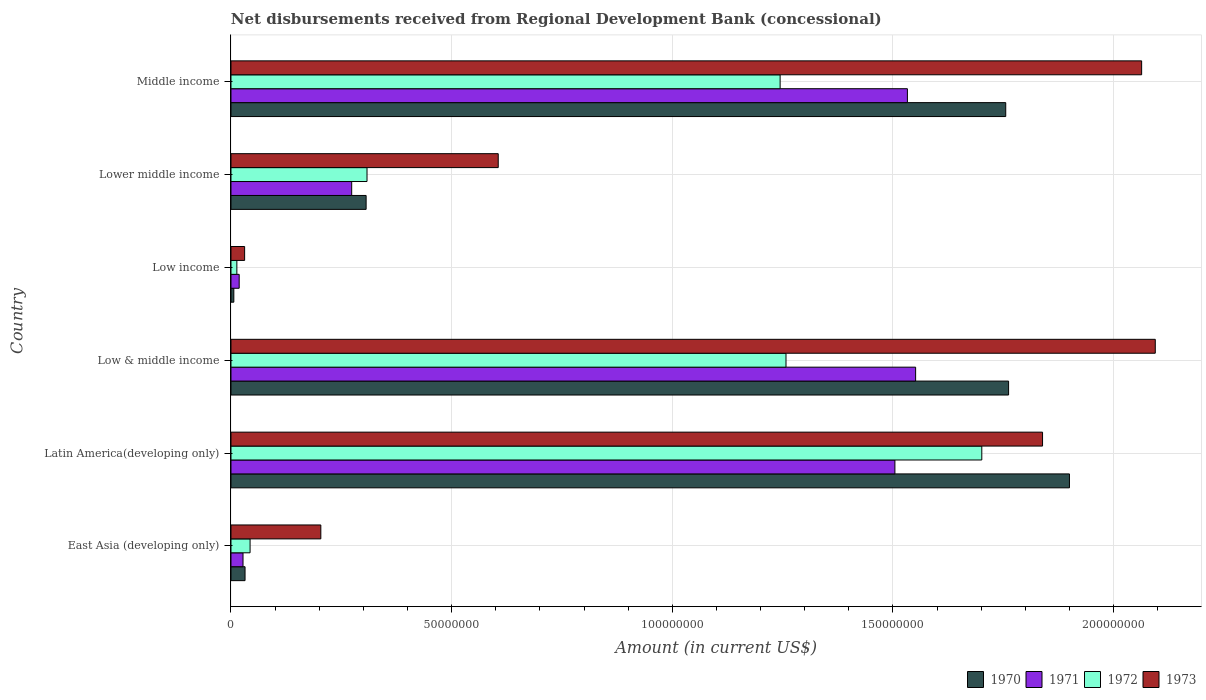How many groups of bars are there?
Give a very brief answer. 6. How many bars are there on the 4th tick from the bottom?
Ensure brevity in your answer.  4. What is the label of the 4th group of bars from the top?
Ensure brevity in your answer.  Low & middle income. What is the amount of disbursements received from Regional Development Bank in 1971 in Low & middle income?
Offer a very short reply. 1.55e+08. Across all countries, what is the maximum amount of disbursements received from Regional Development Bank in 1971?
Keep it short and to the point. 1.55e+08. Across all countries, what is the minimum amount of disbursements received from Regional Development Bank in 1972?
Your answer should be compact. 1.33e+06. What is the total amount of disbursements received from Regional Development Bank in 1970 in the graph?
Offer a terse response. 5.76e+08. What is the difference between the amount of disbursements received from Regional Development Bank in 1973 in East Asia (developing only) and that in Low income?
Give a very brief answer. 1.73e+07. What is the difference between the amount of disbursements received from Regional Development Bank in 1971 in Middle income and the amount of disbursements received from Regional Development Bank in 1973 in East Asia (developing only)?
Your answer should be very brief. 1.33e+08. What is the average amount of disbursements received from Regional Development Bank in 1970 per country?
Provide a short and direct response. 9.60e+07. What is the difference between the amount of disbursements received from Regional Development Bank in 1973 and amount of disbursements received from Regional Development Bank in 1972 in Low & middle income?
Give a very brief answer. 8.37e+07. What is the ratio of the amount of disbursements received from Regional Development Bank in 1973 in Low & middle income to that in Low income?
Offer a terse response. 67.76. Is the amount of disbursements received from Regional Development Bank in 1970 in East Asia (developing only) less than that in Latin America(developing only)?
Your response must be concise. Yes. Is the difference between the amount of disbursements received from Regional Development Bank in 1973 in East Asia (developing only) and Low income greater than the difference between the amount of disbursements received from Regional Development Bank in 1972 in East Asia (developing only) and Low income?
Make the answer very short. Yes. What is the difference between the highest and the second highest amount of disbursements received from Regional Development Bank in 1973?
Give a very brief answer. 3.09e+06. What is the difference between the highest and the lowest amount of disbursements received from Regional Development Bank in 1972?
Make the answer very short. 1.69e+08. Is the sum of the amount of disbursements received from Regional Development Bank in 1973 in Low income and Middle income greater than the maximum amount of disbursements received from Regional Development Bank in 1970 across all countries?
Make the answer very short. Yes. What does the 1st bar from the bottom in Latin America(developing only) represents?
Give a very brief answer. 1970. Is it the case that in every country, the sum of the amount of disbursements received from Regional Development Bank in 1970 and amount of disbursements received from Regional Development Bank in 1971 is greater than the amount of disbursements received from Regional Development Bank in 1972?
Make the answer very short. Yes. How many bars are there?
Provide a short and direct response. 24. Does the graph contain any zero values?
Offer a terse response. No. Does the graph contain grids?
Make the answer very short. Yes. What is the title of the graph?
Your answer should be compact. Net disbursements received from Regional Development Bank (concessional). What is the Amount (in current US$) of 1970 in East Asia (developing only)?
Ensure brevity in your answer.  3.19e+06. What is the Amount (in current US$) in 1971 in East Asia (developing only)?
Offer a very short reply. 2.73e+06. What is the Amount (in current US$) in 1972 in East Asia (developing only)?
Offer a terse response. 4.33e+06. What is the Amount (in current US$) of 1973 in East Asia (developing only)?
Your response must be concise. 2.04e+07. What is the Amount (in current US$) in 1970 in Latin America(developing only)?
Offer a terse response. 1.90e+08. What is the Amount (in current US$) of 1971 in Latin America(developing only)?
Your answer should be compact. 1.50e+08. What is the Amount (in current US$) in 1972 in Latin America(developing only)?
Make the answer very short. 1.70e+08. What is the Amount (in current US$) in 1973 in Latin America(developing only)?
Ensure brevity in your answer.  1.84e+08. What is the Amount (in current US$) of 1970 in Low & middle income?
Give a very brief answer. 1.76e+08. What is the Amount (in current US$) of 1971 in Low & middle income?
Your answer should be compact. 1.55e+08. What is the Amount (in current US$) in 1972 in Low & middle income?
Your answer should be very brief. 1.26e+08. What is the Amount (in current US$) of 1973 in Low & middle income?
Give a very brief answer. 2.09e+08. What is the Amount (in current US$) of 1970 in Low income?
Provide a short and direct response. 6.47e+05. What is the Amount (in current US$) of 1971 in Low income?
Offer a very short reply. 1.86e+06. What is the Amount (in current US$) of 1972 in Low income?
Offer a terse response. 1.33e+06. What is the Amount (in current US$) of 1973 in Low income?
Offer a terse response. 3.09e+06. What is the Amount (in current US$) of 1970 in Lower middle income?
Offer a terse response. 3.06e+07. What is the Amount (in current US$) in 1971 in Lower middle income?
Make the answer very short. 2.74e+07. What is the Amount (in current US$) of 1972 in Lower middle income?
Offer a terse response. 3.08e+07. What is the Amount (in current US$) of 1973 in Lower middle income?
Ensure brevity in your answer.  6.06e+07. What is the Amount (in current US$) of 1970 in Middle income?
Ensure brevity in your answer.  1.76e+08. What is the Amount (in current US$) in 1971 in Middle income?
Keep it short and to the point. 1.53e+08. What is the Amount (in current US$) in 1972 in Middle income?
Offer a terse response. 1.24e+08. What is the Amount (in current US$) of 1973 in Middle income?
Your answer should be very brief. 2.06e+08. Across all countries, what is the maximum Amount (in current US$) in 1970?
Keep it short and to the point. 1.90e+08. Across all countries, what is the maximum Amount (in current US$) in 1971?
Your response must be concise. 1.55e+08. Across all countries, what is the maximum Amount (in current US$) in 1972?
Give a very brief answer. 1.70e+08. Across all countries, what is the maximum Amount (in current US$) in 1973?
Offer a very short reply. 2.09e+08. Across all countries, what is the minimum Amount (in current US$) in 1970?
Your response must be concise. 6.47e+05. Across all countries, what is the minimum Amount (in current US$) of 1971?
Offer a terse response. 1.86e+06. Across all countries, what is the minimum Amount (in current US$) in 1972?
Keep it short and to the point. 1.33e+06. Across all countries, what is the minimum Amount (in current US$) in 1973?
Provide a succinct answer. 3.09e+06. What is the total Amount (in current US$) of 1970 in the graph?
Provide a succinct answer. 5.76e+08. What is the total Amount (in current US$) in 1971 in the graph?
Your response must be concise. 4.91e+08. What is the total Amount (in current US$) of 1972 in the graph?
Give a very brief answer. 4.57e+08. What is the total Amount (in current US$) in 1973 in the graph?
Offer a very short reply. 6.84e+08. What is the difference between the Amount (in current US$) of 1970 in East Asia (developing only) and that in Latin America(developing only)?
Give a very brief answer. -1.87e+08. What is the difference between the Amount (in current US$) in 1971 in East Asia (developing only) and that in Latin America(developing only)?
Provide a short and direct response. -1.48e+08. What is the difference between the Amount (in current US$) of 1972 in East Asia (developing only) and that in Latin America(developing only)?
Offer a very short reply. -1.66e+08. What is the difference between the Amount (in current US$) of 1973 in East Asia (developing only) and that in Latin America(developing only)?
Provide a succinct answer. -1.64e+08. What is the difference between the Amount (in current US$) in 1970 in East Asia (developing only) and that in Low & middle income?
Ensure brevity in your answer.  -1.73e+08. What is the difference between the Amount (in current US$) in 1971 in East Asia (developing only) and that in Low & middle income?
Your response must be concise. -1.52e+08. What is the difference between the Amount (in current US$) of 1972 in East Asia (developing only) and that in Low & middle income?
Your response must be concise. -1.21e+08. What is the difference between the Amount (in current US$) of 1973 in East Asia (developing only) and that in Low & middle income?
Ensure brevity in your answer.  -1.89e+08. What is the difference between the Amount (in current US$) of 1970 in East Asia (developing only) and that in Low income?
Offer a very short reply. 2.54e+06. What is the difference between the Amount (in current US$) in 1971 in East Asia (developing only) and that in Low income?
Offer a very short reply. 8.69e+05. What is the difference between the Amount (in current US$) in 1972 in East Asia (developing only) and that in Low income?
Ensure brevity in your answer.  2.99e+06. What is the difference between the Amount (in current US$) of 1973 in East Asia (developing only) and that in Low income?
Provide a succinct answer. 1.73e+07. What is the difference between the Amount (in current US$) of 1970 in East Asia (developing only) and that in Lower middle income?
Ensure brevity in your answer.  -2.74e+07. What is the difference between the Amount (in current US$) in 1971 in East Asia (developing only) and that in Lower middle income?
Offer a very short reply. -2.46e+07. What is the difference between the Amount (in current US$) in 1972 in East Asia (developing only) and that in Lower middle income?
Your response must be concise. -2.65e+07. What is the difference between the Amount (in current US$) in 1973 in East Asia (developing only) and that in Lower middle income?
Give a very brief answer. -4.02e+07. What is the difference between the Amount (in current US$) in 1970 in East Asia (developing only) and that in Middle income?
Your answer should be compact. -1.72e+08. What is the difference between the Amount (in current US$) of 1971 in East Asia (developing only) and that in Middle income?
Offer a very short reply. -1.51e+08. What is the difference between the Amount (in current US$) in 1972 in East Asia (developing only) and that in Middle income?
Offer a very short reply. -1.20e+08. What is the difference between the Amount (in current US$) in 1973 in East Asia (developing only) and that in Middle income?
Offer a terse response. -1.86e+08. What is the difference between the Amount (in current US$) of 1970 in Latin America(developing only) and that in Low & middle income?
Provide a succinct answer. 1.38e+07. What is the difference between the Amount (in current US$) of 1971 in Latin America(developing only) and that in Low & middle income?
Give a very brief answer. -4.69e+06. What is the difference between the Amount (in current US$) of 1972 in Latin America(developing only) and that in Low & middle income?
Offer a very short reply. 4.44e+07. What is the difference between the Amount (in current US$) in 1973 in Latin America(developing only) and that in Low & middle income?
Keep it short and to the point. -2.55e+07. What is the difference between the Amount (in current US$) of 1970 in Latin America(developing only) and that in Low income?
Offer a very short reply. 1.89e+08. What is the difference between the Amount (in current US$) of 1971 in Latin America(developing only) and that in Low income?
Your response must be concise. 1.49e+08. What is the difference between the Amount (in current US$) of 1972 in Latin America(developing only) and that in Low income?
Give a very brief answer. 1.69e+08. What is the difference between the Amount (in current US$) in 1973 in Latin America(developing only) and that in Low income?
Your answer should be compact. 1.81e+08. What is the difference between the Amount (in current US$) in 1970 in Latin America(developing only) and that in Lower middle income?
Your response must be concise. 1.59e+08. What is the difference between the Amount (in current US$) of 1971 in Latin America(developing only) and that in Lower middle income?
Make the answer very short. 1.23e+08. What is the difference between the Amount (in current US$) of 1972 in Latin America(developing only) and that in Lower middle income?
Provide a succinct answer. 1.39e+08. What is the difference between the Amount (in current US$) of 1973 in Latin America(developing only) and that in Lower middle income?
Your answer should be compact. 1.23e+08. What is the difference between the Amount (in current US$) of 1970 in Latin America(developing only) and that in Middle income?
Offer a terse response. 1.44e+07. What is the difference between the Amount (in current US$) of 1971 in Latin America(developing only) and that in Middle income?
Your answer should be compact. -2.84e+06. What is the difference between the Amount (in current US$) of 1972 in Latin America(developing only) and that in Middle income?
Your answer should be very brief. 4.57e+07. What is the difference between the Amount (in current US$) of 1973 in Latin America(developing only) and that in Middle income?
Your answer should be very brief. -2.25e+07. What is the difference between the Amount (in current US$) in 1970 in Low & middle income and that in Low income?
Offer a very short reply. 1.76e+08. What is the difference between the Amount (in current US$) of 1971 in Low & middle income and that in Low income?
Provide a short and direct response. 1.53e+08. What is the difference between the Amount (in current US$) in 1972 in Low & middle income and that in Low income?
Ensure brevity in your answer.  1.24e+08. What is the difference between the Amount (in current US$) of 1973 in Low & middle income and that in Low income?
Provide a succinct answer. 2.06e+08. What is the difference between the Amount (in current US$) of 1970 in Low & middle income and that in Lower middle income?
Ensure brevity in your answer.  1.46e+08. What is the difference between the Amount (in current US$) of 1971 in Low & middle income and that in Lower middle income?
Provide a succinct answer. 1.28e+08. What is the difference between the Amount (in current US$) in 1972 in Low & middle income and that in Lower middle income?
Ensure brevity in your answer.  9.49e+07. What is the difference between the Amount (in current US$) of 1973 in Low & middle income and that in Lower middle income?
Give a very brief answer. 1.49e+08. What is the difference between the Amount (in current US$) of 1970 in Low & middle income and that in Middle income?
Make the answer very short. 6.47e+05. What is the difference between the Amount (in current US$) of 1971 in Low & middle income and that in Middle income?
Offer a very short reply. 1.86e+06. What is the difference between the Amount (in current US$) of 1972 in Low & middle income and that in Middle income?
Your answer should be compact. 1.33e+06. What is the difference between the Amount (in current US$) in 1973 in Low & middle income and that in Middle income?
Offer a very short reply. 3.09e+06. What is the difference between the Amount (in current US$) of 1970 in Low income and that in Lower middle income?
Your answer should be very brief. -3.00e+07. What is the difference between the Amount (in current US$) of 1971 in Low income and that in Lower middle income?
Offer a terse response. -2.55e+07. What is the difference between the Amount (in current US$) in 1972 in Low income and that in Lower middle income?
Your answer should be very brief. -2.95e+07. What is the difference between the Amount (in current US$) of 1973 in Low income and that in Lower middle income?
Give a very brief answer. -5.75e+07. What is the difference between the Amount (in current US$) in 1970 in Low income and that in Middle income?
Offer a very short reply. -1.75e+08. What is the difference between the Amount (in current US$) in 1971 in Low income and that in Middle income?
Provide a succinct answer. -1.51e+08. What is the difference between the Amount (in current US$) in 1972 in Low income and that in Middle income?
Offer a very short reply. -1.23e+08. What is the difference between the Amount (in current US$) of 1973 in Low income and that in Middle income?
Your answer should be compact. -2.03e+08. What is the difference between the Amount (in current US$) of 1970 in Lower middle income and that in Middle income?
Keep it short and to the point. -1.45e+08. What is the difference between the Amount (in current US$) in 1971 in Lower middle income and that in Middle income?
Make the answer very short. -1.26e+08. What is the difference between the Amount (in current US$) of 1972 in Lower middle income and that in Middle income?
Keep it short and to the point. -9.36e+07. What is the difference between the Amount (in current US$) in 1973 in Lower middle income and that in Middle income?
Provide a succinct answer. -1.46e+08. What is the difference between the Amount (in current US$) of 1970 in East Asia (developing only) and the Amount (in current US$) of 1971 in Latin America(developing only)?
Offer a terse response. -1.47e+08. What is the difference between the Amount (in current US$) in 1970 in East Asia (developing only) and the Amount (in current US$) in 1972 in Latin America(developing only)?
Your answer should be compact. -1.67e+08. What is the difference between the Amount (in current US$) of 1970 in East Asia (developing only) and the Amount (in current US$) of 1973 in Latin America(developing only)?
Keep it short and to the point. -1.81e+08. What is the difference between the Amount (in current US$) in 1971 in East Asia (developing only) and the Amount (in current US$) in 1972 in Latin America(developing only)?
Your response must be concise. -1.67e+08. What is the difference between the Amount (in current US$) of 1971 in East Asia (developing only) and the Amount (in current US$) of 1973 in Latin America(developing only)?
Your response must be concise. -1.81e+08. What is the difference between the Amount (in current US$) of 1972 in East Asia (developing only) and the Amount (in current US$) of 1973 in Latin America(developing only)?
Provide a succinct answer. -1.80e+08. What is the difference between the Amount (in current US$) of 1970 in East Asia (developing only) and the Amount (in current US$) of 1971 in Low & middle income?
Give a very brief answer. -1.52e+08. What is the difference between the Amount (in current US$) of 1970 in East Asia (developing only) and the Amount (in current US$) of 1972 in Low & middle income?
Give a very brief answer. -1.23e+08. What is the difference between the Amount (in current US$) in 1970 in East Asia (developing only) and the Amount (in current US$) in 1973 in Low & middle income?
Your answer should be very brief. -2.06e+08. What is the difference between the Amount (in current US$) of 1971 in East Asia (developing only) and the Amount (in current US$) of 1972 in Low & middle income?
Your response must be concise. -1.23e+08. What is the difference between the Amount (in current US$) in 1971 in East Asia (developing only) and the Amount (in current US$) in 1973 in Low & middle income?
Your answer should be very brief. -2.07e+08. What is the difference between the Amount (in current US$) of 1972 in East Asia (developing only) and the Amount (in current US$) of 1973 in Low & middle income?
Keep it short and to the point. -2.05e+08. What is the difference between the Amount (in current US$) in 1970 in East Asia (developing only) and the Amount (in current US$) in 1971 in Low income?
Provide a short and direct response. 1.33e+06. What is the difference between the Amount (in current US$) of 1970 in East Asia (developing only) and the Amount (in current US$) of 1972 in Low income?
Your response must be concise. 1.86e+06. What is the difference between the Amount (in current US$) in 1970 in East Asia (developing only) and the Amount (in current US$) in 1973 in Low income?
Ensure brevity in your answer.  9.80e+04. What is the difference between the Amount (in current US$) in 1971 in East Asia (developing only) and the Amount (in current US$) in 1972 in Low income?
Keep it short and to the point. 1.40e+06. What is the difference between the Amount (in current US$) of 1971 in East Asia (developing only) and the Amount (in current US$) of 1973 in Low income?
Provide a short and direct response. -3.63e+05. What is the difference between the Amount (in current US$) of 1972 in East Asia (developing only) and the Amount (in current US$) of 1973 in Low income?
Offer a terse response. 1.24e+06. What is the difference between the Amount (in current US$) of 1970 in East Asia (developing only) and the Amount (in current US$) of 1971 in Lower middle income?
Offer a terse response. -2.42e+07. What is the difference between the Amount (in current US$) of 1970 in East Asia (developing only) and the Amount (in current US$) of 1972 in Lower middle income?
Ensure brevity in your answer.  -2.76e+07. What is the difference between the Amount (in current US$) in 1970 in East Asia (developing only) and the Amount (in current US$) in 1973 in Lower middle income?
Provide a succinct answer. -5.74e+07. What is the difference between the Amount (in current US$) of 1971 in East Asia (developing only) and the Amount (in current US$) of 1972 in Lower middle income?
Offer a terse response. -2.81e+07. What is the difference between the Amount (in current US$) in 1971 in East Asia (developing only) and the Amount (in current US$) in 1973 in Lower middle income?
Ensure brevity in your answer.  -5.78e+07. What is the difference between the Amount (in current US$) of 1972 in East Asia (developing only) and the Amount (in current US$) of 1973 in Lower middle income?
Provide a succinct answer. -5.62e+07. What is the difference between the Amount (in current US$) in 1970 in East Asia (developing only) and the Amount (in current US$) in 1971 in Middle income?
Provide a succinct answer. -1.50e+08. What is the difference between the Amount (in current US$) in 1970 in East Asia (developing only) and the Amount (in current US$) in 1972 in Middle income?
Your answer should be very brief. -1.21e+08. What is the difference between the Amount (in current US$) in 1970 in East Asia (developing only) and the Amount (in current US$) in 1973 in Middle income?
Give a very brief answer. -2.03e+08. What is the difference between the Amount (in current US$) of 1971 in East Asia (developing only) and the Amount (in current US$) of 1972 in Middle income?
Provide a short and direct response. -1.22e+08. What is the difference between the Amount (in current US$) of 1971 in East Asia (developing only) and the Amount (in current US$) of 1973 in Middle income?
Provide a short and direct response. -2.04e+08. What is the difference between the Amount (in current US$) of 1972 in East Asia (developing only) and the Amount (in current US$) of 1973 in Middle income?
Ensure brevity in your answer.  -2.02e+08. What is the difference between the Amount (in current US$) of 1970 in Latin America(developing only) and the Amount (in current US$) of 1971 in Low & middle income?
Make the answer very short. 3.49e+07. What is the difference between the Amount (in current US$) in 1970 in Latin America(developing only) and the Amount (in current US$) in 1972 in Low & middle income?
Keep it short and to the point. 6.42e+07. What is the difference between the Amount (in current US$) of 1970 in Latin America(developing only) and the Amount (in current US$) of 1973 in Low & middle income?
Your response must be concise. -1.94e+07. What is the difference between the Amount (in current US$) of 1971 in Latin America(developing only) and the Amount (in current US$) of 1972 in Low & middle income?
Make the answer very short. 2.47e+07. What is the difference between the Amount (in current US$) in 1971 in Latin America(developing only) and the Amount (in current US$) in 1973 in Low & middle income?
Keep it short and to the point. -5.90e+07. What is the difference between the Amount (in current US$) in 1972 in Latin America(developing only) and the Amount (in current US$) in 1973 in Low & middle income?
Ensure brevity in your answer.  -3.93e+07. What is the difference between the Amount (in current US$) in 1970 in Latin America(developing only) and the Amount (in current US$) in 1971 in Low income?
Offer a very short reply. 1.88e+08. What is the difference between the Amount (in current US$) of 1970 in Latin America(developing only) and the Amount (in current US$) of 1972 in Low income?
Provide a short and direct response. 1.89e+08. What is the difference between the Amount (in current US$) in 1970 in Latin America(developing only) and the Amount (in current US$) in 1973 in Low income?
Make the answer very short. 1.87e+08. What is the difference between the Amount (in current US$) in 1971 in Latin America(developing only) and the Amount (in current US$) in 1972 in Low income?
Give a very brief answer. 1.49e+08. What is the difference between the Amount (in current US$) in 1971 in Latin America(developing only) and the Amount (in current US$) in 1973 in Low income?
Keep it short and to the point. 1.47e+08. What is the difference between the Amount (in current US$) in 1972 in Latin America(developing only) and the Amount (in current US$) in 1973 in Low income?
Give a very brief answer. 1.67e+08. What is the difference between the Amount (in current US$) of 1970 in Latin America(developing only) and the Amount (in current US$) of 1971 in Lower middle income?
Offer a terse response. 1.63e+08. What is the difference between the Amount (in current US$) of 1970 in Latin America(developing only) and the Amount (in current US$) of 1972 in Lower middle income?
Offer a terse response. 1.59e+08. What is the difference between the Amount (in current US$) in 1970 in Latin America(developing only) and the Amount (in current US$) in 1973 in Lower middle income?
Offer a terse response. 1.29e+08. What is the difference between the Amount (in current US$) of 1971 in Latin America(developing only) and the Amount (in current US$) of 1972 in Lower middle income?
Make the answer very short. 1.20e+08. What is the difference between the Amount (in current US$) in 1971 in Latin America(developing only) and the Amount (in current US$) in 1973 in Lower middle income?
Your answer should be compact. 8.99e+07. What is the difference between the Amount (in current US$) of 1972 in Latin America(developing only) and the Amount (in current US$) of 1973 in Lower middle income?
Your answer should be compact. 1.10e+08. What is the difference between the Amount (in current US$) of 1970 in Latin America(developing only) and the Amount (in current US$) of 1971 in Middle income?
Give a very brief answer. 3.67e+07. What is the difference between the Amount (in current US$) of 1970 in Latin America(developing only) and the Amount (in current US$) of 1972 in Middle income?
Offer a terse response. 6.56e+07. What is the difference between the Amount (in current US$) of 1970 in Latin America(developing only) and the Amount (in current US$) of 1973 in Middle income?
Keep it short and to the point. -1.64e+07. What is the difference between the Amount (in current US$) of 1971 in Latin America(developing only) and the Amount (in current US$) of 1972 in Middle income?
Provide a short and direct response. 2.60e+07. What is the difference between the Amount (in current US$) of 1971 in Latin America(developing only) and the Amount (in current US$) of 1973 in Middle income?
Ensure brevity in your answer.  -5.59e+07. What is the difference between the Amount (in current US$) of 1972 in Latin America(developing only) and the Amount (in current US$) of 1973 in Middle income?
Your answer should be very brief. -3.62e+07. What is the difference between the Amount (in current US$) in 1970 in Low & middle income and the Amount (in current US$) in 1971 in Low income?
Offer a very short reply. 1.74e+08. What is the difference between the Amount (in current US$) in 1970 in Low & middle income and the Amount (in current US$) in 1972 in Low income?
Offer a terse response. 1.75e+08. What is the difference between the Amount (in current US$) in 1970 in Low & middle income and the Amount (in current US$) in 1973 in Low income?
Your answer should be compact. 1.73e+08. What is the difference between the Amount (in current US$) of 1971 in Low & middle income and the Amount (in current US$) of 1972 in Low income?
Make the answer very short. 1.54e+08. What is the difference between the Amount (in current US$) of 1971 in Low & middle income and the Amount (in current US$) of 1973 in Low income?
Your answer should be very brief. 1.52e+08. What is the difference between the Amount (in current US$) in 1972 in Low & middle income and the Amount (in current US$) in 1973 in Low income?
Ensure brevity in your answer.  1.23e+08. What is the difference between the Amount (in current US$) in 1970 in Low & middle income and the Amount (in current US$) in 1971 in Lower middle income?
Give a very brief answer. 1.49e+08. What is the difference between the Amount (in current US$) in 1970 in Low & middle income and the Amount (in current US$) in 1972 in Lower middle income?
Your answer should be compact. 1.45e+08. What is the difference between the Amount (in current US$) of 1970 in Low & middle income and the Amount (in current US$) of 1973 in Lower middle income?
Give a very brief answer. 1.16e+08. What is the difference between the Amount (in current US$) of 1971 in Low & middle income and the Amount (in current US$) of 1972 in Lower middle income?
Ensure brevity in your answer.  1.24e+08. What is the difference between the Amount (in current US$) of 1971 in Low & middle income and the Amount (in current US$) of 1973 in Lower middle income?
Keep it short and to the point. 9.46e+07. What is the difference between the Amount (in current US$) of 1972 in Low & middle income and the Amount (in current US$) of 1973 in Lower middle income?
Provide a short and direct response. 6.52e+07. What is the difference between the Amount (in current US$) of 1970 in Low & middle income and the Amount (in current US$) of 1971 in Middle income?
Offer a terse response. 2.29e+07. What is the difference between the Amount (in current US$) of 1970 in Low & middle income and the Amount (in current US$) of 1972 in Middle income?
Give a very brief answer. 5.18e+07. What is the difference between the Amount (in current US$) of 1970 in Low & middle income and the Amount (in current US$) of 1973 in Middle income?
Your answer should be very brief. -3.01e+07. What is the difference between the Amount (in current US$) of 1971 in Low & middle income and the Amount (in current US$) of 1972 in Middle income?
Offer a terse response. 3.07e+07. What is the difference between the Amount (in current US$) in 1971 in Low & middle income and the Amount (in current US$) in 1973 in Middle income?
Your answer should be very brief. -5.12e+07. What is the difference between the Amount (in current US$) of 1972 in Low & middle income and the Amount (in current US$) of 1973 in Middle income?
Give a very brief answer. -8.06e+07. What is the difference between the Amount (in current US$) of 1970 in Low income and the Amount (in current US$) of 1971 in Lower middle income?
Your answer should be compact. -2.67e+07. What is the difference between the Amount (in current US$) in 1970 in Low income and the Amount (in current US$) in 1972 in Lower middle income?
Provide a succinct answer. -3.02e+07. What is the difference between the Amount (in current US$) in 1970 in Low income and the Amount (in current US$) in 1973 in Lower middle income?
Offer a terse response. -5.99e+07. What is the difference between the Amount (in current US$) of 1971 in Low income and the Amount (in current US$) of 1972 in Lower middle income?
Provide a succinct answer. -2.90e+07. What is the difference between the Amount (in current US$) in 1971 in Low income and the Amount (in current US$) in 1973 in Lower middle income?
Your answer should be very brief. -5.87e+07. What is the difference between the Amount (in current US$) in 1972 in Low income and the Amount (in current US$) in 1973 in Lower middle income?
Offer a very short reply. -5.92e+07. What is the difference between the Amount (in current US$) of 1970 in Low income and the Amount (in current US$) of 1971 in Middle income?
Ensure brevity in your answer.  -1.53e+08. What is the difference between the Amount (in current US$) of 1970 in Low income and the Amount (in current US$) of 1972 in Middle income?
Provide a short and direct response. -1.24e+08. What is the difference between the Amount (in current US$) of 1970 in Low income and the Amount (in current US$) of 1973 in Middle income?
Provide a succinct answer. -2.06e+08. What is the difference between the Amount (in current US$) of 1971 in Low income and the Amount (in current US$) of 1972 in Middle income?
Your answer should be compact. -1.23e+08. What is the difference between the Amount (in current US$) in 1971 in Low income and the Amount (in current US$) in 1973 in Middle income?
Offer a terse response. -2.04e+08. What is the difference between the Amount (in current US$) of 1972 in Low income and the Amount (in current US$) of 1973 in Middle income?
Keep it short and to the point. -2.05e+08. What is the difference between the Amount (in current US$) in 1970 in Lower middle income and the Amount (in current US$) in 1971 in Middle income?
Keep it short and to the point. -1.23e+08. What is the difference between the Amount (in current US$) of 1970 in Lower middle income and the Amount (in current US$) of 1972 in Middle income?
Make the answer very short. -9.38e+07. What is the difference between the Amount (in current US$) in 1970 in Lower middle income and the Amount (in current US$) in 1973 in Middle income?
Your answer should be very brief. -1.76e+08. What is the difference between the Amount (in current US$) of 1971 in Lower middle income and the Amount (in current US$) of 1972 in Middle income?
Keep it short and to the point. -9.71e+07. What is the difference between the Amount (in current US$) of 1971 in Lower middle income and the Amount (in current US$) of 1973 in Middle income?
Provide a succinct answer. -1.79e+08. What is the difference between the Amount (in current US$) in 1972 in Lower middle income and the Amount (in current US$) in 1973 in Middle income?
Ensure brevity in your answer.  -1.76e+08. What is the average Amount (in current US$) in 1970 per country?
Keep it short and to the point. 9.60e+07. What is the average Amount (in current US$) in 1971 per country?
Provide a short and direct response. 8.18e+07. What is the average Amount (in current US$) of 1972 per country?
Keep it short and to the point. 7.61e+07. What is the average Amount (in current US$) in 1973 per country?
Offer a very short reply. 1.14e+08. What is the difference between the Amount (in current US$) of 1970 and Amount (in current US$) of 1971 in East Asia (developing only)?
Your answer should be compact. 4.61e+05. What is the difference between the Amount (in current US$) in 1970 and Amount (in current US$) in 1972 in East Asia (developing only)?
Your response must be concise. -1.14e+06. What is the difference between the Amount (in current US$) of 1970 and Amount (in current US$) of 1973 in East Asia (developing only)?
Give a very brief answer. -1.72e+07. What is the difference between the Amount (in current US$) of 1971 and Amount (in current US$) of 1972 in East Asia (developing only)?
Your response must be concise. -1.60e+06. What is the difference between the Amount (in current US$) of 1971 and Amount (in current US$) of 1973 in East Asia (developing only)?
Offer a very short reply. -1.76e+07. What is the difference between the Amount (in current US$) of 1972 and Amount (in current US$) of 1973 in East Asia (developing only)?
Provide a short and direct response. -1.60e+07. What is the difference between the Amount (in current US$) of 1970 and Amount (in current US$) of 1971 in Latin America(developing only)?
Provide a succinct answer. 3.96e+07. What is the difference between the Amount (in current US$) of 1970 and Amount (in current US$) of 1972 in Latin America(developing only)?
Ensure brevity in your answer.  1.99e+07. What is the difference between the Amount (in current US$) of 1970 and Amount (in current US$) of 1973 in Latin America(developing only)?
Your answer should be compact. 6.10e+06. What is the difference between the Amount (in current US$) in 1971 and Amount (in current US$) in 1972 in Latin America(developing only)?
Offer a very short reply. -1.97e+07. What is the difference between the Amount (in current US$) in 1971 and Amount (in current US$) in 1973 in Latin America(developing only)?
Keep it short and to the point. -3.35e+07. What is the difference between the Amount (in current US$) in 1972 and Amount (in current US$) in 1973 in Latin America(developing only)?
Keep it short and to the point. -1.38e+07. What is the difference between the Amount (in current US$) of 1970 and Amount (in current US$) of 1971 in Low & middle income?
Your answer should be compact. 2.11e+07. What is the difference between the Amount (in current US$) in 1970 and Amount (in current US$) in 1972 in Low & middle income?
Provide a succinct answer. 5.04e+07. What is the difference between the Amount (in current US$) of 1970 and Amount (in current US$) of 1973 in Low & middle income?
Keep it short and to the point. -3.32e+07. What is the difference between the Amount (in current US$) of 1971 and Amount (in current US$) of 1972 in Low & middle income?
Your answer should be compact. 2.94e+07. What is the difference between the Amount (in current US$) in 1971 and Amount (in current US$) in 1973 in Low & middle income?
Ensure brevity in your answer.  -5.43e+07. What is the difference between the Amount (in current US$) in 1972 and Amount (in current US$) in 1973 in Low & middle income?
Your answer should be compact. -8.37e+07. What is the difference between the Amount (in current US$) in 1970 and Amount (in current US$) in 1971 in Low income?
Your response must be concise. -1.21e+06. What is the difference between the Amount (in current US$) in 1970 and Amount (in current US$) in 1972 in Low income?
Your answer should be compact. -6.86e+05. What is the difference between the Amount (in current US$) in 1970 and Amount (in current US$) in 1973 in Low income?
Offer a terse response. -2.44e+06. What is the difference between the Amount (in current US$) of 1971 and Amount (in current US$) of 1972 in Low income?
Provide a succinct answer. 5.26e+05. What is the difference between the Amount (in current US$) of 1971 and Amount (in current US$) of 1973 in Low income?
Make the answer very short. -1.23e+06. What is the difference between the Amount (in current US$) of 1972 and Amount (in current US$) of 1973 in Low income?
Keep it short and to the point. -1.76e+06. What is the difference between the Amount (in current US$) of 1970 and Amount (in current US$) of 1971 in Lower middle income?
Your response must be concise. 3.27e+06. What is the difference between the Amount (in current US$) of 1970 and Amount (in current US$) of 1972 in Lower middle income?
Give a very brief answer. -2.02e+05. What is the difference between the Amount (in current US$) in 1970 and Amount (in current US$) in 1973 in Lower middle income?
Provide a succinct answer. -2.99e+07. What is the difference between the Amount (in current US$) of 1971 and Amount (in current US$) of 1972 in Lower middle income?
Make the answer very short. -3.47e+06. What is the difference between the Amount (in current US$) in 1971 and Amount (in current US$) in 1973 in Lower middle income?
Make the answer very short. -3.32e+07. What is the difference between the Amount (in current US$) in 1972 and Amount (in current US$) in 1973 in Lower middle income?
Your response must be concise. -2.97e+07. What is the difference between the Amount (in current US$) in 1970 and Amount (in current US$) in 1971 in Middle income?
Provide a succinct answer. 2.23e+07. What is the difference between the Amount (in current US$) of 1970 and Amount (in current US$) of 1972 in Middle income?
Your response must be concise. 5.11e+07. What is the difference between the Amount (in current US$) of 1970 and Amount (in current US$) of 1973 in Middle income?
Ensure brevity in your answer.  -3.08e+07. What is the difference between the Amount (in current US$) in 1971 and Amount (in current US$) in 1972 in Middle income?
Ensure brevity in your answer.  2.88e+07. What is the difference between the Amount (in current US$) in 1971 and Amount (in current US$) in 1973 in Middle income?
Offer a very short reply. -5.31e+07. What is the difference between the Amount (in current US$) of 1972 and Amount (in current US$) of 1973 in Middle income?
Give a very brief answer. -8.19e+07. What is the ratio of the Amount (in current US$) of 1970 in East Asia (developing only) to that in Latin America(developing only)?
Ensure brevity in your answer.  0.02. What is the ratio of the Amount (in current US$) in 1971 in East Asia (developing only) to that in Latin America(developing only)?
Ensure brevity in your answer.  0.02. What is the ratio of the Amount (in current US$) of 1972 in East Asia (developing only) to that in Latin America(developing only)?
Keep it short and to the point. 0.03. What is the ratio of the Amount (in current US$) in 1973 in East Asia (developing only) to that in Latin America(developing only)?
Your answer should be compact. 0.11. What is the ratio of the Amount (in current US$) of 1970 in East Asia (developing only) to that in Low & middle income?
Offer a terse response. 0.02. What is the ratio of the Amount (in current US$) in 1971 in East Asia (developing only) to that in Low & middle income?
Offer a terse response. 0.02. What is the ratio of the Amount (in current US$) in 1972 in East Asia (developing only) to that in Low & middle income?
Make the answer very short. 0.03. What is the ratio of the Amount (in current US$) in 1973 in East Asia (developing only) to that in Low & middle income?
Give a very brief answer. 0.1. What is the ratio of the Amount (in current US$) of 1970 in East Asia (developing only) to that in Low income?
Ensure brevity in your answer.  4.93. What is the ratio of the Amount (in current US$) of 1971 in East Asia (developing only) to that in Low income?
Ensure brevity in your answer.  1.47. What is the ratio of the Amount (in current US$) in 1972 in East Asia (developing only) to that in Low income?
Your answer should be compact. 3.25. What is the ratio of the Amount (in current US$) in 1973 in East Asia (developing only) to that in Low income?
Your answer should be very brief. 6.59. What is the ratio of the Amount (in current US$) in 1970 in East Asia (developing only) to that in Lower middle income?
Your answer should be compact. 0.1. What is the ratio of the Amount (in current US$) in 1971 in East Asia (developing only) to that in Lower middle income?
Give a very brief answer. 0.1. What is the ratio of the Amount (in current US$) of 1972 in East Asia (developing only) to that in Lower middle income?
Provide a short and direct response. 0.14. What is the ratio of the Amount (in current US$) in 1973 in East Asia (developing only) to that in Lower middle income?
Make the answer very short. 0.34. What is the ratio of the Amount (in current US$) of 1970 in East Asia (developing only) to that in Middle income?
Give a very brief answer. 0.02. What is the ratio of the Amount (in current US$) of 1971 in East Asia (developing only) to that in Middle income?
Give a very brief answer. 0.02. What is the ratio of the Amount (in current US$) of 1972 in East Asia (developing only) to that in Middle income?
Provide a succinct answer. 0.03. What is the ratio of the Amount (in current US$) in 1973 in East Asia (developing only) to that in Middle income?
Give a very brief answer. 0.1. What is the ratio of the Amount (in current US$) of 1970 in Latin America(developing only) to that in Low & middle income?
Offer a very short reply. 1.08. What is the ratio of the Amount (in current US$) in 1971 in Latin America(developing only) to that in Low & middle income?
Offer a very short reply. 0.97. What is the ratio of the Amount (in current US$) in 1972 in Latin America(developing only) to that in Low & middle income?
Provide a succinct answer. 1.35. What is the ratio of the Amount (in current US$) of 1973 in Latin America(developing only) to that in Low & middle income?
Ensure brevity in your answer.  0.88. What is the ratio of the Amount (in current US$) of 1970 in Latin America(developing only) to that in Low income?
Offer a very short reply. 293.65. What is the ratio of the Amount (in current US$) in 1971 in Latin America(developing only) to that in Low income?
Offer a terse response. 80.93. What is the ratio of the Amount (in current US$) in 1972 in Latin America(developing only) to that in Low income?
Give a very brief answer. 127.63. What is the ratio of the Amount (in current US$) of 1973 in Latin America(developing only) to that in Low income?
Keep it short and to the point. 59.49. What is the ratio of the Amount (in current US$) in 1970 in Latin America(developing only) to that in Lower middle income?
Your answer should be compact. 6.2. What is the ratio of the Amount (in current US$) in 1971 in Latin America(developing only) to that in Lower middle income?
Provide a short and direct response. 5.5. What is the ratio of the Amount (in current US$) of 1972 in Latin America(developing only) to that in Lower middle income?
Make the answer very short. 5.52. What is the ratio of the Amount (in current US$) of 1973 in Latin America(developing only) to that in Lower middle income?
Your response must be concise. 3.04. What is the ratio of the Amount (in current US$) in 1970 in Latin America(developing only) to that in Middle income?
Your response must be concise. 1.08. What is the ratio of the Amount (in current US$) of 1971 in Latin America(developing only) to that in Middle income?
Your answer should be very brief. 0.98. What is the ratio of the Amount (in current US$) in 1972 in Latin America(developing only) to that in Middle income?
Keep it short and to the point. 1.37. What is the ratio of the Amount (in current US$) of 1973 in Latin America(developing only) to that in Middle income?
Offer a very short reply. 0.89. What is the ratio of the Amount (in current US$) in 1970 in Low & middle income to that in Low income?
Your response must be concise. 272.33. What is the ratio of the Amount (in current US$) of 1971 in Low & middle income to that in Low income?
Give a very brief answer. 83.45. What is the ratio of the Amount (in current US$) in 1972 in Low & middle income to that in Low income?
Your answer should be compact. 94.35. What is the ratio of the Amount (in current US$) of 1973 in Low & middle income to that in Low income?
Provide a succinct answer. 67.76. What is the ratio of the Amount (in current US$) in 1970 in Low & middle income to that in Lower middle income?
Your answer should be compact. 5.75. What is the ratio of the Amount (in current US$) in 1971 in Low & middle income to that in Lower middle income?
Provide a succinct answer. 5.67. What is the ratio of the Amount (in current US$) of 1972 in Low & middle income to that in Lower middle income?
Ensure brevity in your answer.  4.08. What is the ratio of the Amount (in current US$) of 1973 in Low & middle income to that in Lower middle income?
Your answer should be very brief. 3.46. What is the ratio of the Amount (in current US$) of 1971 in Low & middle income to that in Middle income?
Your answer should be compact. 1.01. What is the ratio of the Amount (in current US$) in 1972 in Low & middle income to that in Middle income?
Ensure brevity in your answer.  1.01. What is the ratio of the Amount (in current US$) of 1970 in Low income to that in Lower middle income?
Ensure brevity in your answer.  0.02. What is the ratio of the Amount (in current US$) of 1971 in Low income to that in Lower middle income?
Keep it short and to the point. 0.07. What is the ratio of the Amount (in current US$) of 1972 in Low income to that in Lower middle income?
Provide a succinct answer. 0.04. What is the ratio of the Amount (in current US$) of 1973 in Low income to that in Lower middle income?
Offer a very short reply. 0.05. What is the ratio of the Amount (in current US$) of 1970 in Low income to that in Middle income?
Give a very brief answer. 0. What is the ratio of the Amount (in current US$) of 1971 in Low income to that in Middle income?
Offer a terse response. 0.01. What is the ratio of the Amount (in current US$) of 1972 in Low income to that in Middle income?
Provide a succinct answer. 0.01. What is the ratio of the Amount (in current US$) of 1973 in Low income to that in Middle income?
Make the answer very short. 0.01. What is the ratio of the Amount (in current US$) of 1970 in Lower middle income to that in Middle income?
Give a very brief answer. 0.17. What is the ratio of the Amount (in current US$) in 1971 in Lower middle income to that in Middle income?
Ensure brevity in your answer.  0.18. What is the ratio of the Amount (in current US$) of 1972 in Lower middle income to that in Middle income?
Keep it short and to the point. 0.25. What is the ratio of the Amount (in current US$) of 1973 in Lower middle income to that in Middle income?
Make the answer very short. 0.29. What is the difference between the highest and the second highest Amount (in current US$) in 1970?
Your answer should be compact. 1.38e+07. What is the difference between the highest and the second highest Amount (in current US$) in 1971?
Keep it short and to the point. 1.86e+06. What is the difference between the highest and the second highest Amount (in current US$) in 1972?
Keep it short and to the point. 4.44e+07. What is the difference between the highest and the second highest Amount (in current US$) of 1973?
Provide a short and direct response. 3.09e+06. What is the difference between the highest and the lowest Amount (in current US$) of 1970?
Provide a succinct answer. 1.89e+08. What is the difference between the highest and the lowest Amount (in current US$) of 1971?
Your response must be concise. 1.53e+08. What is the difference between the highest and the lowest Amount (in current US$) in 1972?
Provide a short and direct response. 1.69e+08. What is the difference between the highest and the lowest Amount (in current US$) in 1973?
Offer a very short reply. 2.06e+08. 